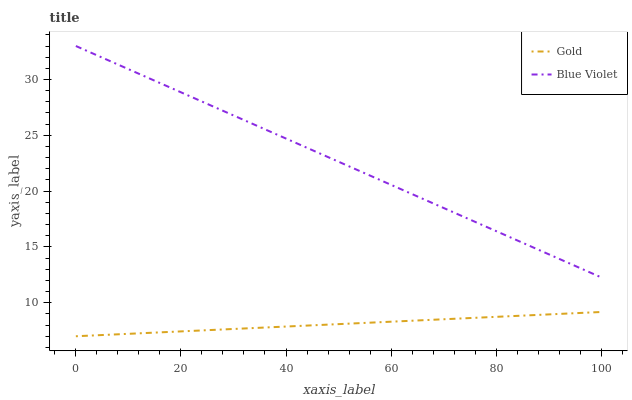Does Gold have the minimum area under the curve?
Answer yes or no. Yes. Does Blue Violet have the maximum area under the curve?
Answer yes or no. Yes. Does Gold have the maximum area under the curve?
Answer yes or no. No. Is Gold the smoothest?
Answer yes or no. Yes. Is Blue Violet the roughest?
Answer yes or no. Yes. Is Gold the roughest?
Answer yes or no. No. Does Gold have the highest value?
Answer yes or no. No. Is Gold less than Blue Violet?
Answer yes or no. Yes. Is Blue Violet greater than Gold?
Answer yes or no. Yes. Does Gold intersect Blue Violet?
Answer yes or no. No. 